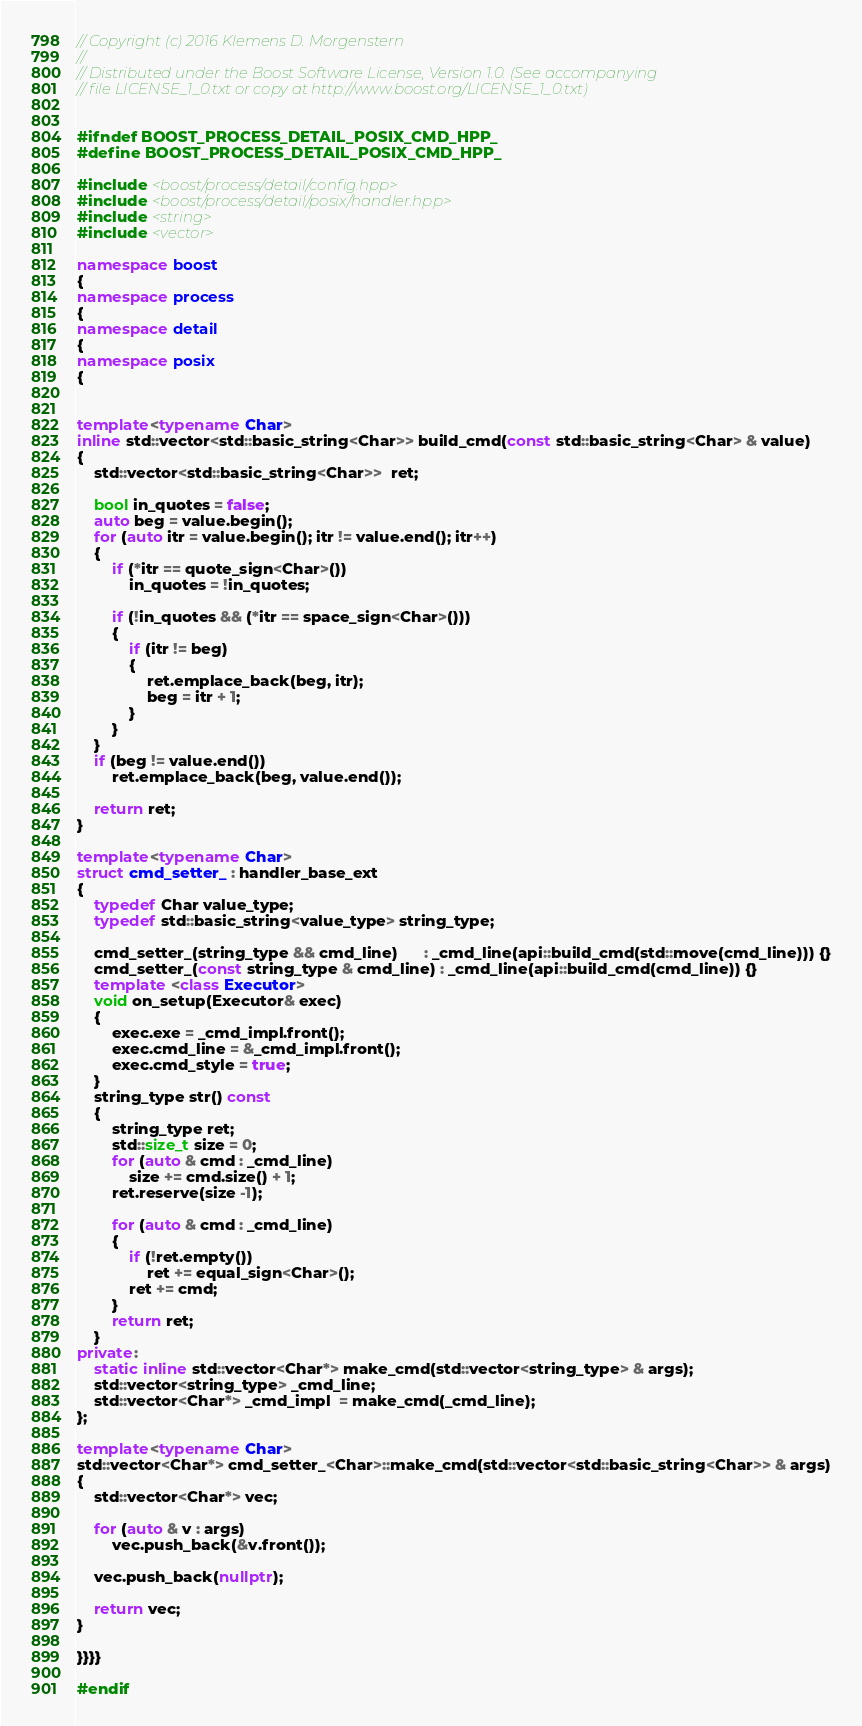<code> <loc_0><loc_0><loc_500><loc_500><_C++_>// Copyright (c) 2016 Klemens D. Morgenstern
//
// Distributed under the Boost Software License, Version 1.0. (See accompanying
// file LICENSE_1_0.txt or copy at http://www.boost.org/LICENSE_1_0.txt)


#ifndef BOOST_PROCESS_DETAIL_POSIX_CMD_HPP_
#define BOOST_PROCESS_DETAIL_POSIX_CMD_HPP_

#include <boost/process/detail/config.hpp>
#include <boost/process/detail/posix/handler.hpp>
#include <string>
#include <vector>

namespace boost
{
namespace process
{
namespace detail
{
namespace posix
{


template<typename Char>
inline std::vector<std::basic_string<Char>> build_cmd(const std::basic_string<Char> & value)
{
    std::vector<std::basic_string<Char>>  ret;

    bool in_quotes = false;
    auto beg = value.begin();
    for (auto itr = value.begin(); itr != value.end(); itr++)
    {
        if (*itr == quote_sign<Char>())
            in_quotes = !in_quotes;

        if (!in_quotes && (*itr == space_sign<Char>()))
        {
            if (itr != beg)
            {
                ret.emplace_back(beg, itr);
                beg = itr + 1;
            }
        }
    }
    if (beg != value.end())
        ret.emplace_back(beg, value.end());

    return ret;
}

template<typename Char>
struct cmd_setter_ : handler_base_ext
{
    typedef Char value_type;
    typedef std::basic_string<value_type> string_type;

    cmd_setter_(string_type && cmd_line)      : _cmd_line(api::build_cmd(std::move(cmd_line))) {}
    cmd_setter_(const string_type & cmd_line) : _cmd_line(api::build_cmd(cmd_line)) {}
    template <class Executor>
    void on_setup(Executor& exec) 
    {
        exec.exe = _cmd_impl.front();
        exec.cmd_line = &_cmd_impl.front();
        exec.cmd_style = true;
    }
    string_type str() const
    {
        string_type ret;
        std::size_t size = 0;
        for (auto & cmd : _cmd_line)
            size += cmd.size() + 1;
        ret.reserve(size -1);

        for (auto & cmd : _cmd_line)
        {
            if (!ret.empty())
                ret += equal_sign<Char>();
            ret += cmd;
        }
        return ret;
    }
private:
    static inline std::vector<Char*> make_cmd(std::vector<string_type> & args);
    std::vector<string_type> _cmd_line;
    std::vector<Char*> _cmd_impl  = make_cmd(_cmd_line);
};

template<typename Char>
std::vector<Char*> cmd_setter_<Char>::make_cmd(std::vector<std::basic_string<Char>> & args)
{
    std::vector<Char*> vec;

    for (auto & v : args)
        vec.push_back(&v.front());

    vec.push_back(nullptr);

    return vec;
}

}}}}

#endif
</code> 